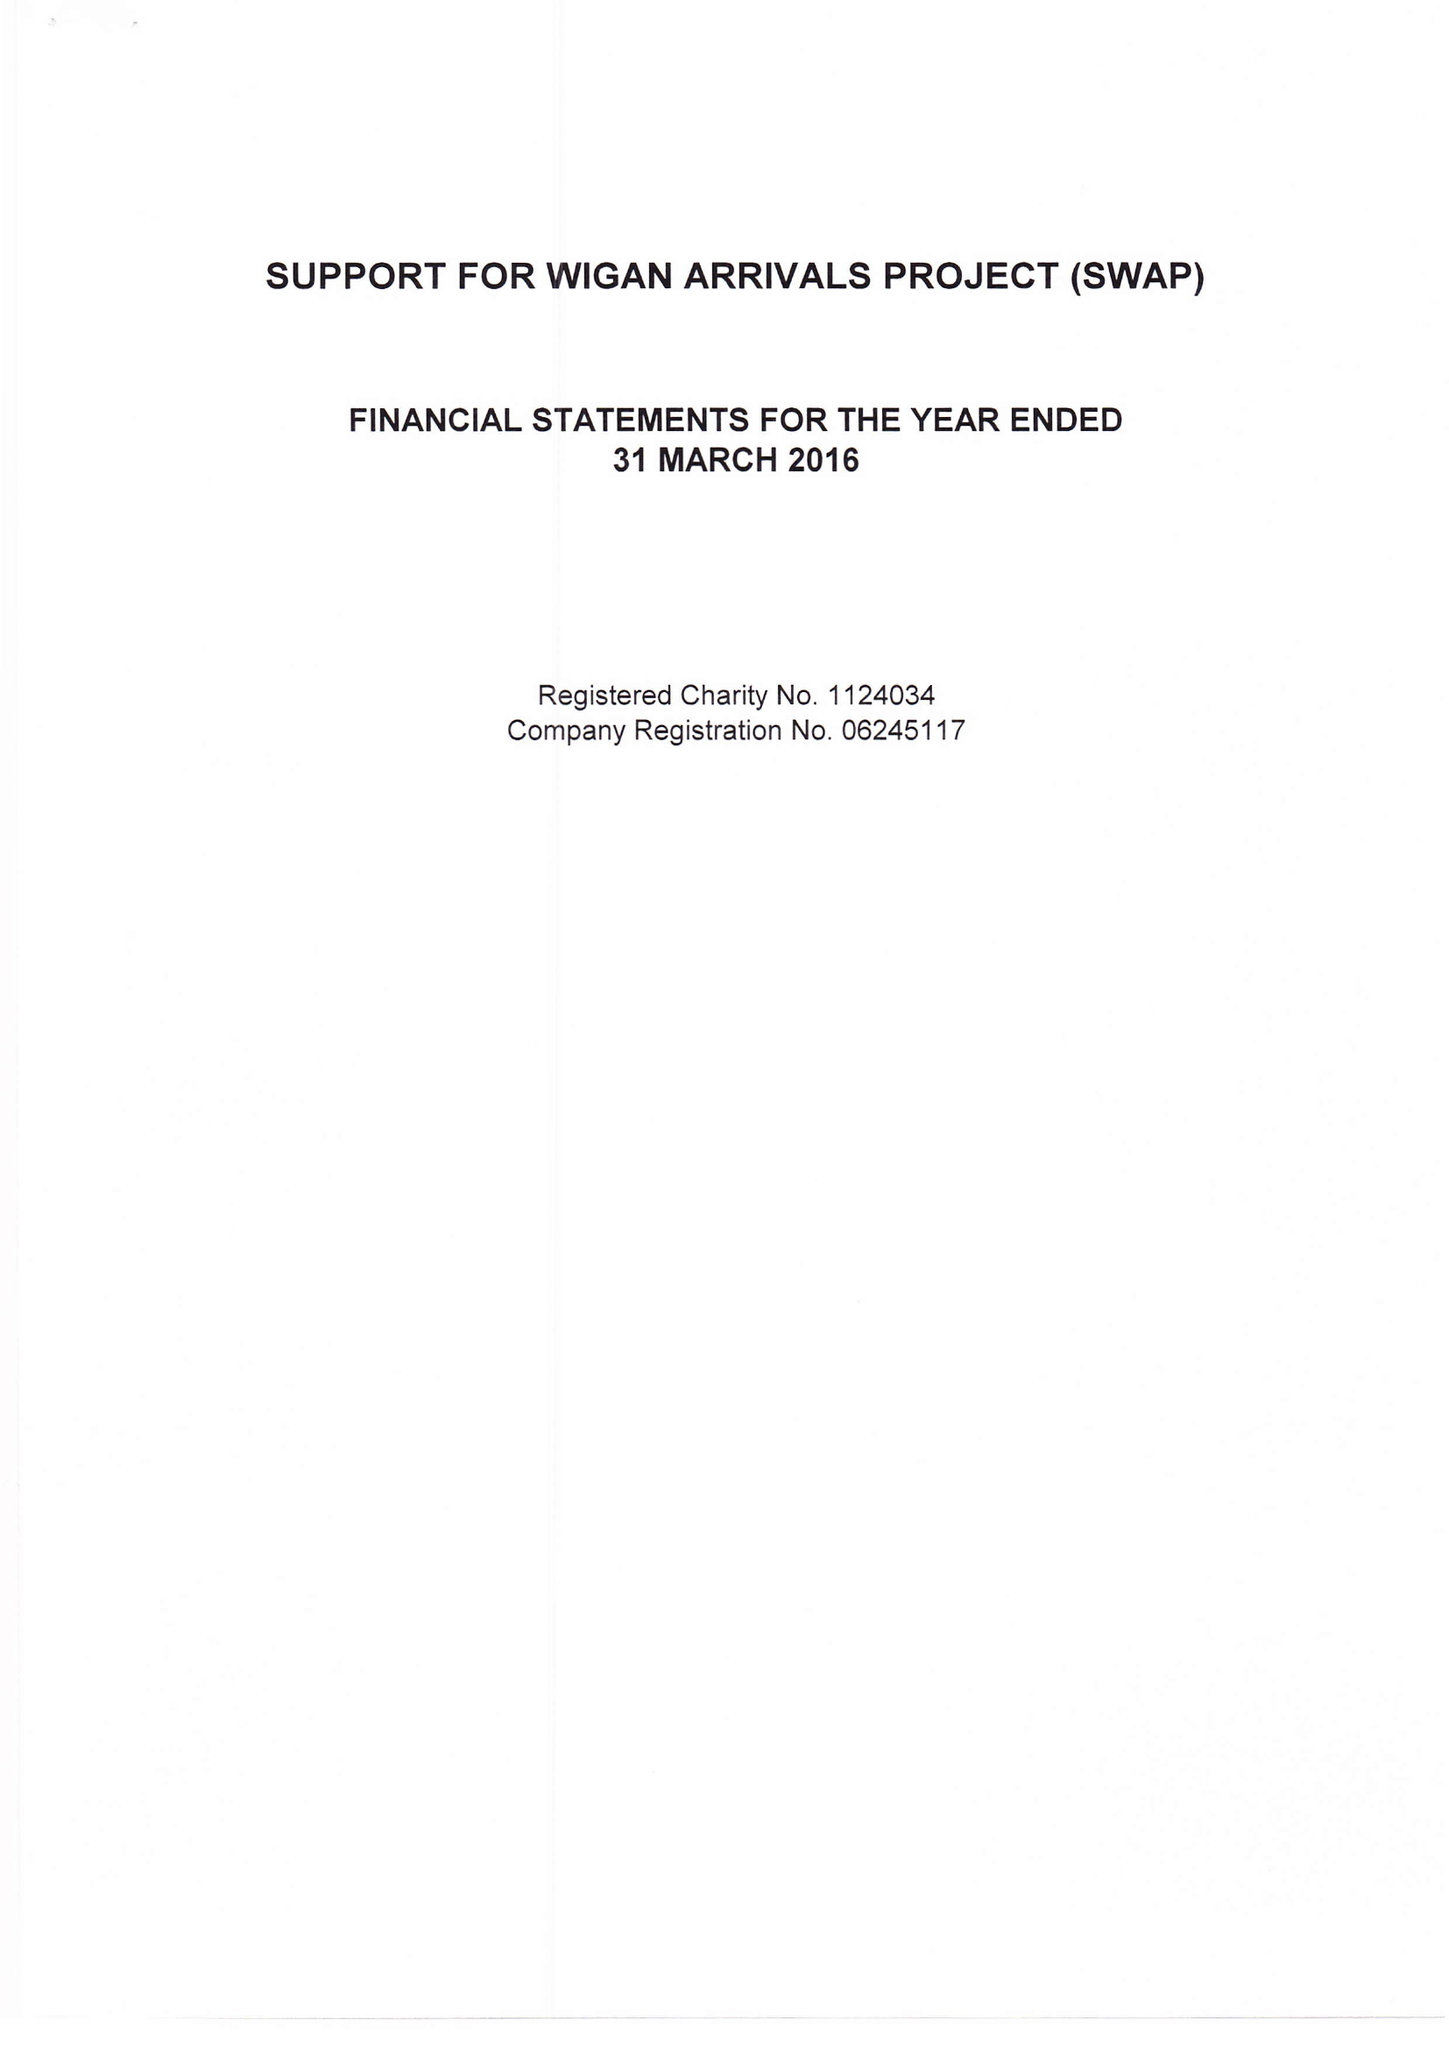What is the value for the charity_name?
Answer the question using a single word or phrase. Support For Wigan Arrivals Project 